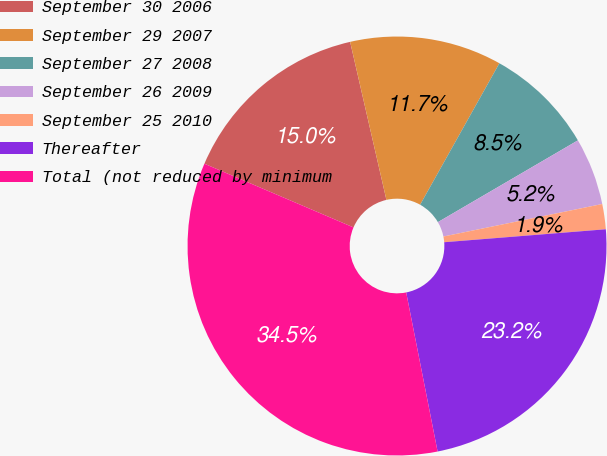<chart> <loc_0><loc_0><loc_500><loc_500><pie_chart><fcel>September 30 2006<fcel>September 29 2007<fcel>September 27 2008<fcel>September 26 2009<fcel>September 25 2010<fcel>Thereafter<fcel>Total (not reduced by minimum<nl><fcel>14.98%<fcel>11.72%<fcel>8.46%<fcel>5.2%<fcel>1.94%<fcel>23.17%<fcel>34.53%<nl></chart> 